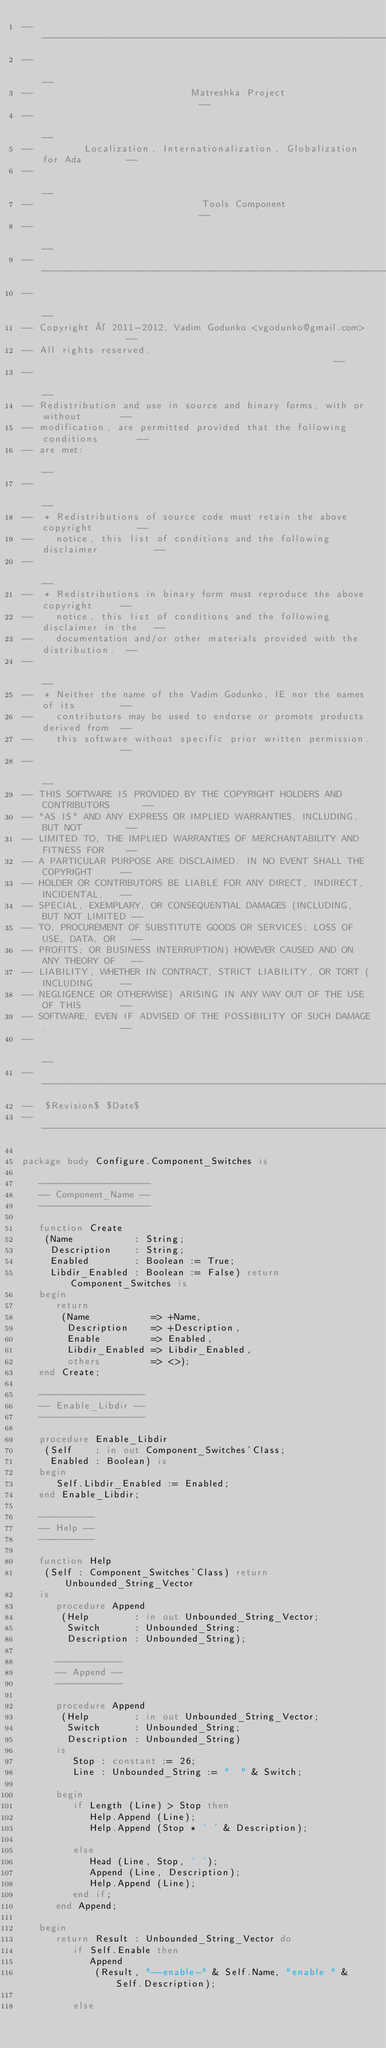Convert code to text. <code><loc_0><loc_0><loc_500><loc_500><_Ada_>------------------------------------------------------------------------------
--                                                                          --
--                            Matreshka Project                             --
--                                                                          --
--         Localization, Internationalization, Globalization for Ada        --
--                                                                          --
--                              Tools Component                             --
--                                                                          --
------------------------------------------------------------------------------
--                                                                          --
-- Copyright © 2011-2012, Vadim Godunko <vgodunko@gmail.com>                --
-- All rights reserved.                                                     --
--                                                                          --
-- Redistribution and use in source and binary forms, with or without       --
-- modification, are permitted provided that the following conditions       --
-- are met:                                                                 --
--                                                                          --
--  * Redistributions of source code must retain the above copyright        --
--    notice, this list of conditions and the following disclaimer.         --
--                                                                          --
--  * Redistributions in binary form must reproduce the above copyright     --
--    notice, this list of conditions and the following disclaimer in the   --
--    documentation and/or other materials provided with the distribution.  --
--                                                                          --
--  * Neither the name of the Vadim Godunko, IE nor the names of its        --
--    contributors may be used to endorse or promote products derived from  --
--    this software without specific prior written permission.              --
--                                                                          --
-- THIS SOFTWARE IS PROVIDED BY THE COPYRIGHT HOLDERS AND CONTRIBUTORS      --
-- "AS IS" AND ANY EXPRESS OR IMPLIED WARRANTIES, INCLUDING, BUT NOT        --
-- LIMITED TO, THE IMPLIED WARRANTIES OF MERCHANTABILITY AND FITNESS FOR    --
-- A PARTICULAR PURPOSE ARE DISCLAIMED. IN NO EVENT SHALL THE COPYRIGHT     --
-- HOLDER OR CONTRIBUTORS BE LIABLE FOR ANY DIRECT, INDIRECT, INCIDENTAL,   --
-- SPECIAL, EXEMPLARY, OR CONSEQUENTIAL DAMAGES (INCLUDING, BUT NOT LIMITED --
-- TO, PROCUREMENT OF SUBSTITUTE GOODS OR SERVICES; LOSS OF USE, DATA, OR   --
-- PROFITS; OR BUSINESS INTERRUPTION) HOWEVER CAUSED AND ON ANY THEORY OF   --
-- LIABILITY, WHETHER IN CONTRACT, STRICT LIABILITY, OR TORT (INCLUDING     --
-- NEGLIGENCE OR OTHERWISE) ARISING IN ANY WAY OUT OF THE USE OF THIS       --
-- SOFTWARE, EVEN IF ADVISED OF THE POSSIBILITY OF SUCH DAMAGE.             --
--                                                                          --
------------------------------------------------------------------------------
--  $Revision$ $Date$
------------------------------------------------------------------------------

package body Configure.Component_Switches is

   --------------------
   -- Component_Name --
   --------------------

   function Create
    (Name           : String;
     Description    : String;
     Enabled        : Boolean := True;
     Libdir_Enabled : Boolean := False) return Component_Switches is
   begin
      return
       (Name           => +Name,
        Description    => +Description,
        Enable         => Enabled,
        Libdir_Enabled => Libdir_Enabled,
        others         => <>);
   end Create;

   -------------------
   -- Enable_Libdir --
   -------------------

   procedure Enable_Libdir
    (Self    : in out Component_Switches'Class;
     Enabled : Boolean) is
   begin
      Self.Libdir_Enabled := Enabled;
   end Enable_Libdir;

   ----------
   -- Help --
   ----------

   function Help
    (Self : Component_Switches'Class) return Unbounded_String_Vector
   is
      procedure Append
       (Help        : in out Unbounded_String_Vector;
        Switch      : Unbounded_String;
        Description : Unbounded_String);

      ------------
      -- Append --
      ------------

      procedure Append
       (Help        : in out Unbounded_String_Vector;
        Switch      : Unbounded_String;
        Description : Unbounded_String)
      is
         Stop : constant := 26;
         Line : Unbounded_String := "  " & Switch;

      begin
         if Length (Line) > Stop then
            Help.Append (Line);
            Help.Append (Stop * ' ' & Description);

         else
            Head (Line, Stop, ' ');
            Append (Line, Description);
            Help.Append (Line);
         end if;
      end Append;

   begin
      return Result : Unbounded_String_Vector do
         if Self.Enable then
            Append
             (Result, "--enable-" & Self.Name, "enable " & Self.Description);

         else</code> 